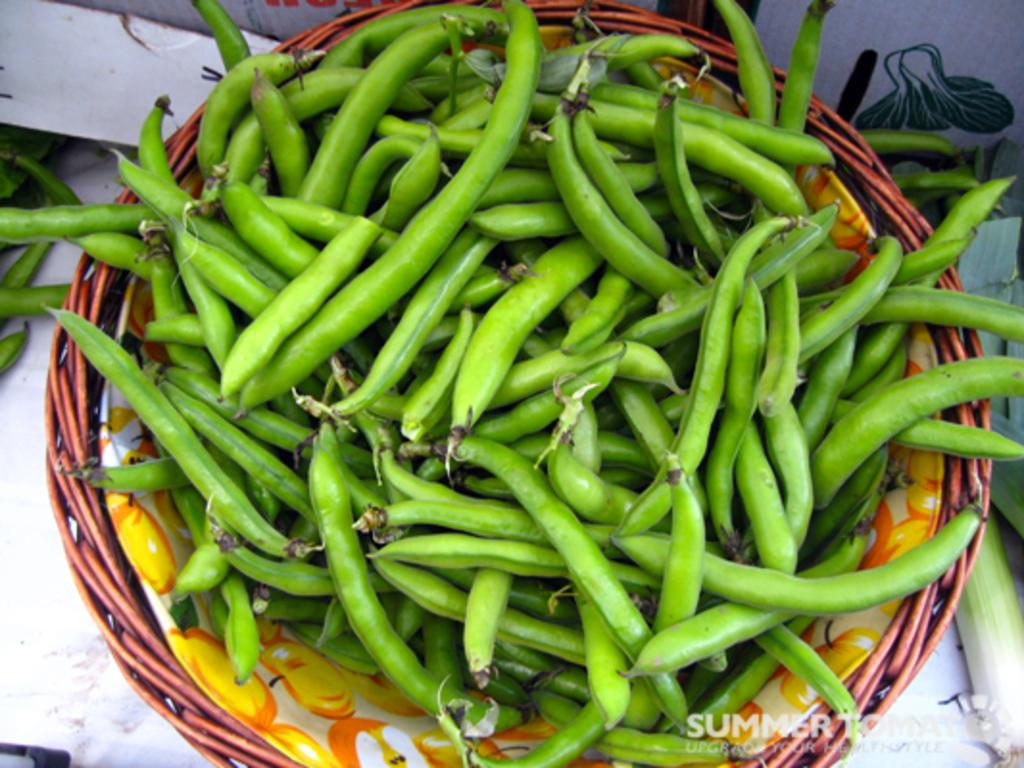What type of food items are present in the image? There are vegetables in a basket in the image. Can you describe the arrangement of the vegetables? The vegetables are in a basket, which suggests they are organized and contained. What might be the purpose of having vegetables in a basket? The vegetables in a basket might be for storage, display, or preparation purposes. What type of cake is being shared between the sister and her friends in the image? There is no cake or sister present in the image; it only features vegetables in a basket. 